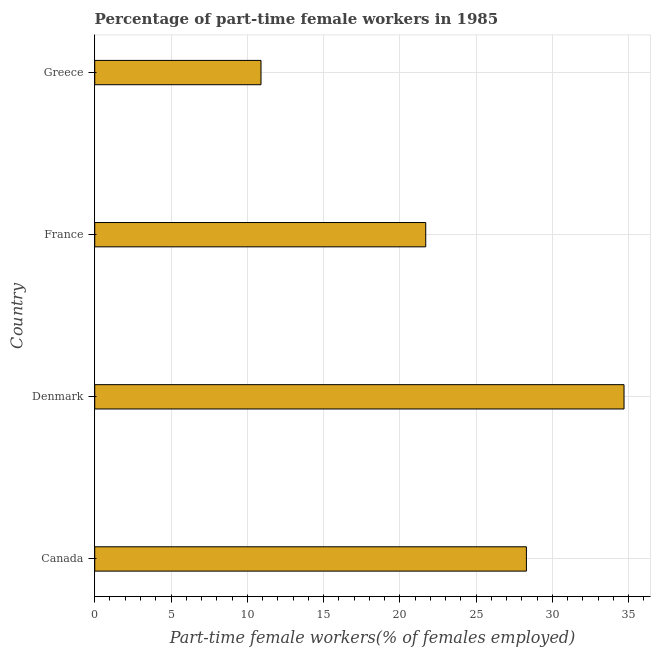What is the title of the graph?
Offer a terse response. Percentage of part-time female workers in 1985. What is the label or title of the X-axis?
Offer a very short reply. Part-time female workers(% of females employed). What is the percentage of part-time female workers in France?
Offer a very short reply. 21.7. Across all countries, what is the maximum percentage of part-time female workers?
Offer a terse response. 34.7. Across all countries, what is the minimum percentage of part-time female workers?
Offer a terse response. 10.9. In which country was the percentage of part-time female workers maximum?
Offer a terse response. Denmark. In which country was the percentage of part-time female workers minimum?
Offer a very short reply. Greece. What is the sum of the percentage of part-time female workers?
Provide a succinct answer. 95.6. What is the average percentage of part-time female workers per country?
Your answer should be compact. 23.9. In how many countries, is the percentage of part-time female workers greater than 12 %?
Make the answer very short. 3. What is the ratio of the percentage of part-time female workers in Canada to that in France?
Give a very brief answer. 1.3. Is the percentage of part-time female workers in Denmark less than that in France?
Your answer should be compact. No. Is the difference between the percentage of part-time female workers in Canada and Denmark greater than the difference between any two countries?
Give a very brief answer. No. What is the difference between the highest and the second highest percentage of part-time female workers?
Keep it short and to the point. 6.4. Is the sum of the percentage of part-time female workers in Canada and Greece greater than the maximum percentage of part-time female workers across all countries?
Your answer should be very brief. Yes. What is the difference between the highest and the lowest percentage of part-time female workers?
Your answer should be very brief. 23.8. In how many countries, is the percentage of part-time female workers greater than the average percentage of part-time female workers taken over all countries?
Your answer should be very brief. 2. How many bars are there?
Provide a succinct answer. 4. What is the difference between two consecutive major ticks on the X-axis?
Make the answer very short. 5. What is the Part-time female workers(% of females employed) in Canada?
Your answer should be compact. 28.3. What is the Part-time female workers(% of females employed) in Denmark?
Provide a succinct answer. 34.7. What is the Part-time female workers(% of females employed) of France?
Provide a succinct answer. 21.7. What is the Part-time female workers(% of females employed) in Greece?
Your answer should be very brief. 10.9. What is the difference between the Part-time female workers(% of females employed) in Canada and Greece?
Your response must be concise. 17.4. What is the difference between the Part-time female workers(% of females employed) in Denmark and Greece?
Provide a short and direct response. 23.8. What is the ratio of the Part-time female workers(% of females employed) in Canada to that in Denmark?
Provide a succinct answer. 0.82. What is the ratio of the Part-time female workers(% of females employed) in Canada to that in France?
Offer a very short reply. 1.3. What is the ratio of the Part-time female workers(% of females employed) in Canada to that in Greece?
Keep it short and to the point. 2.6. What is the ratio of the Part-time female workers(% of females employed) in Denmark to that in France?
Offer a terse response. 1.6. What is the ratio of the Part-time female workers(% of females employed) in Denmark to that in Greece?
Your answer should be very brief. 3.18. What is the ratio of the Part-time female workers(% of females employed) in France to that in Greece?
Provide a succinct answer. 1.99. 